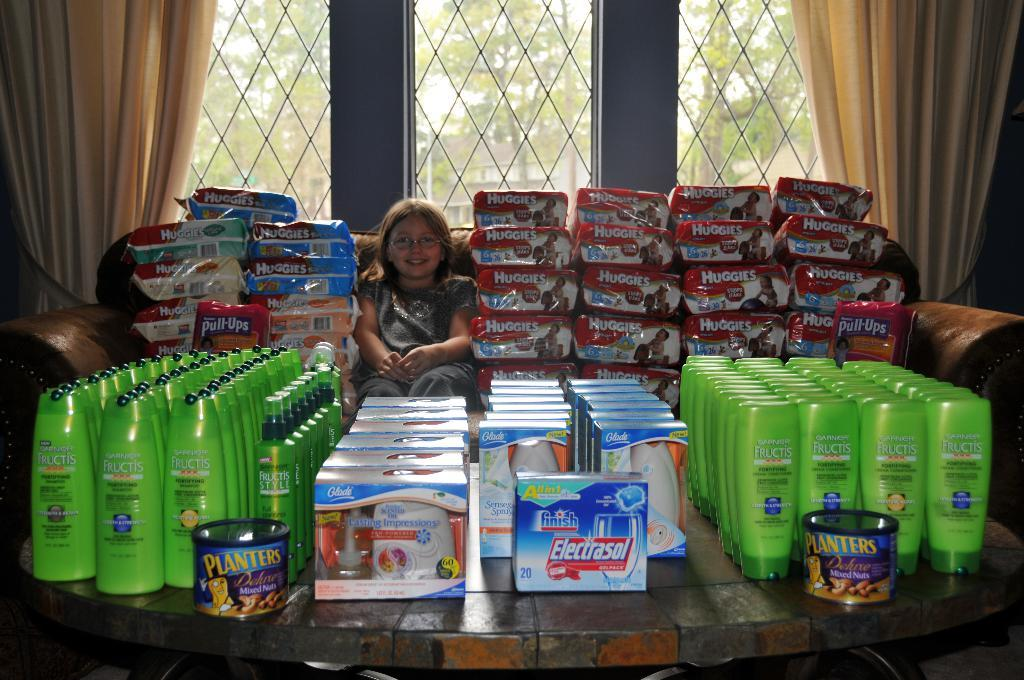Provide a one-sentence caption for the provided image. a girl posing next to huggies diapers and nuts. 